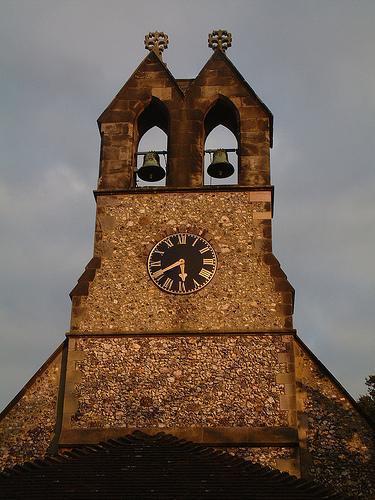How many bells are there?
Give a very brief answer. 2. 